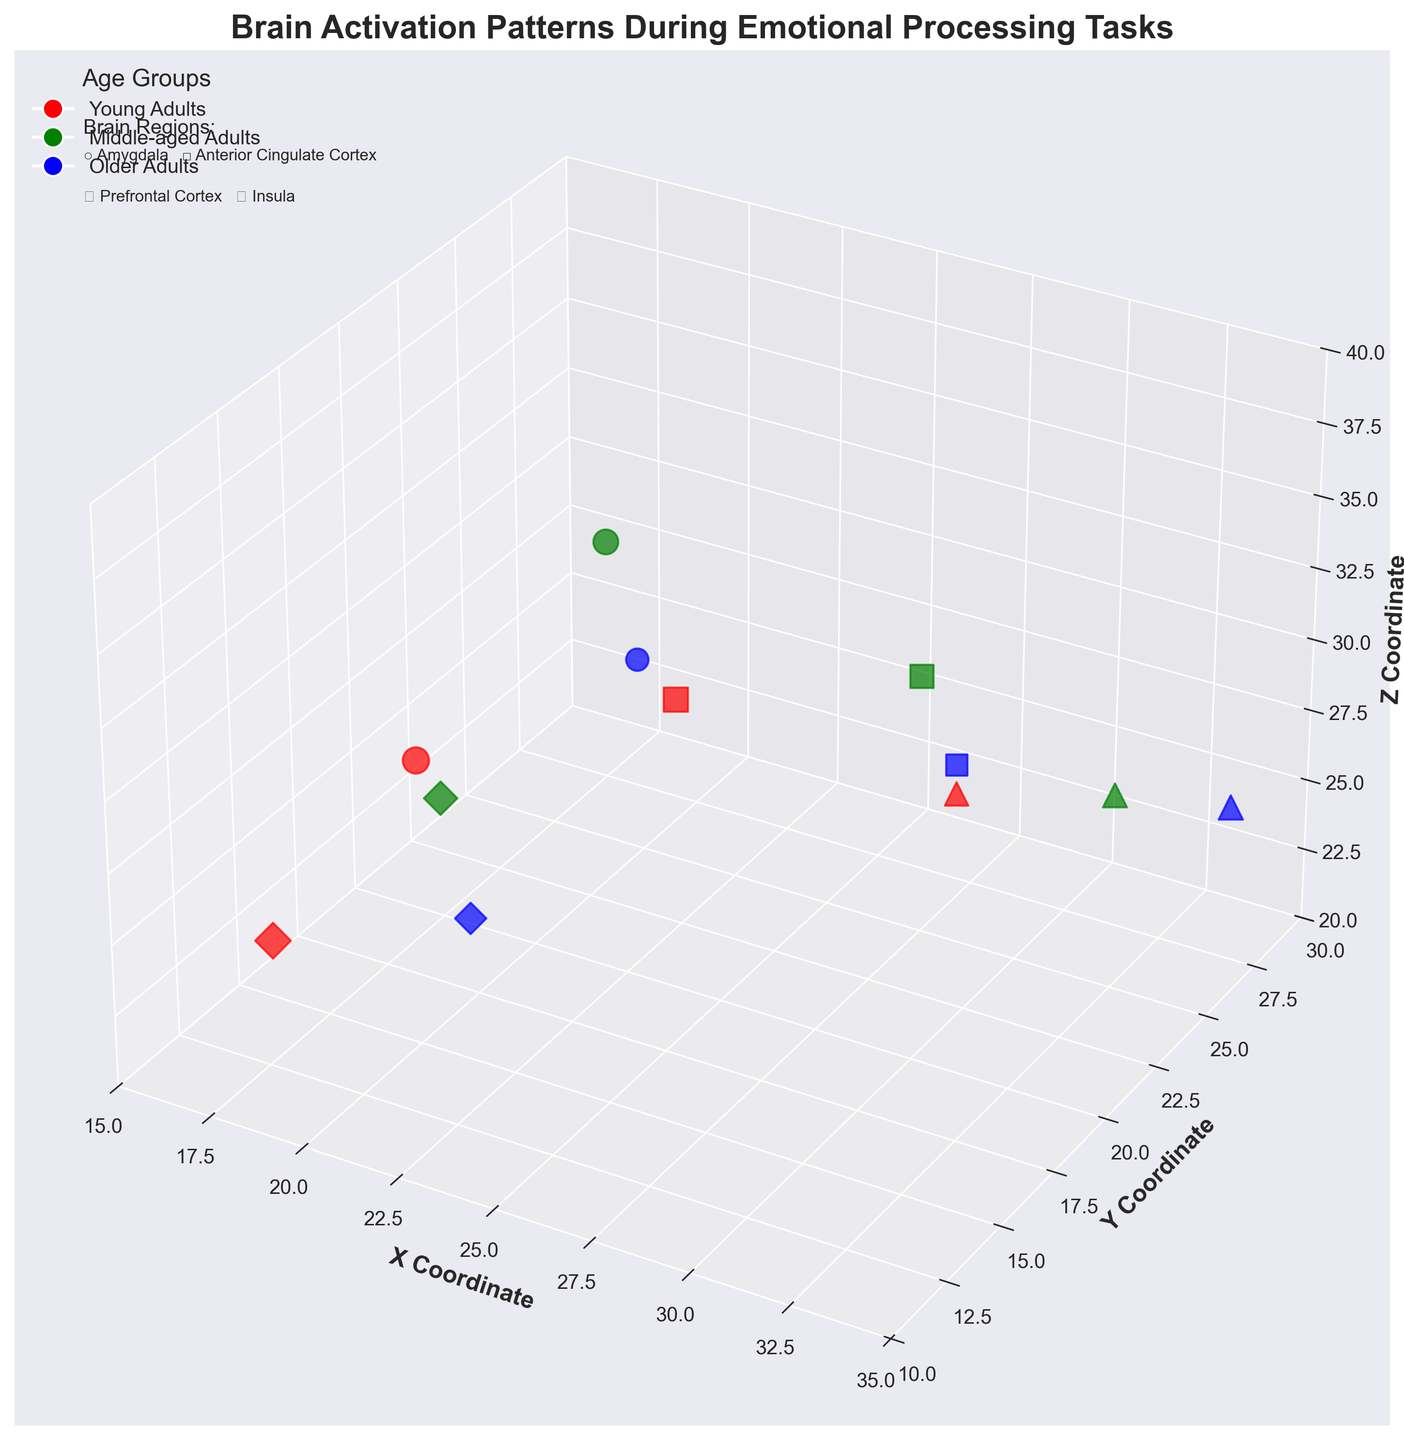what is the title of the figure? The title is usually displayed at the top of the figure. It provides a brief summary of what the figure represents.
Answer: Brain Activation Patterns During Emotional Processing Tasks What are the axes labels in this figure? Axes labels are typically found beside the axes, providing context for what the axes represent. In this figure, they label the spatial coordinates.
Answer: X Coordinate, Y Coordinate, Z Coordinate How many data points are represented for the 'Older Adults' group? Data points are indicated by markers and colored blue for the 'Older Adults' group. By counting the markers of this color, we can find the number of data points.
Answer: 4 Which brain region in 'Young Adults' has the highest activation level? By looking at the markers for 'Young Adults' (red) and comparing their sizes (which represent activation levels), we can identify the largest marker.
Answer: Amygdala What is the range of x-coordinates used in the figure? The range is determined by the minimum and maximum values indicated on the x-axis.
Answer: 15 to 35 What brain region is represented by square markers, and what age group does it belong to? The legend and text description near the figure provide this information, showing which marker corresponds to which brain region and age group.
Answer: Anterior Cingulate Cortex, applies to all age groups Which has a higher activation level: the 'Prefrontal Cortex' in 'Middle-aged Adults' or the 'Prefrontal Cortex' in 'Older Adults'? To compare, observe the colors (green for 'Middle-aged Adults' and blue for 'Older Adults') and the sizes of the triangle markers.
Answer: Older Adults What are the coordinates of the data point with the highest activation level in the 'Middle-aged Adults' group? This requires identifying the largest green marker and noting its position coordinates.
Answer: (32, 26, 26) Which age group has the highest overall activation in the 'Amygdala' based on marker size? Spot the 'Amygdala' markers across all age groups and compare their sizes.
Answer: Young Adults 